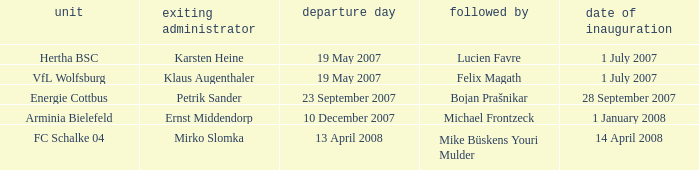When was the appointment date for VFL Wolfsburg? 1 July 2007. 